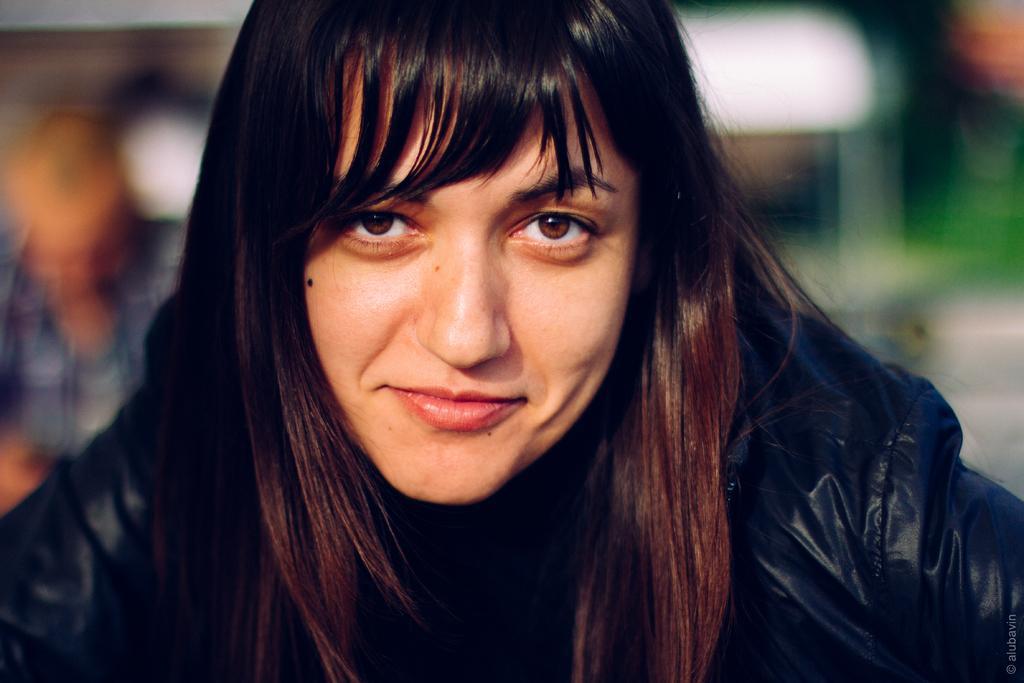Could you give a brief overview of what you see in this image? This is the picture of a woman wearing a black dress. In this image we can see background as a blur. 